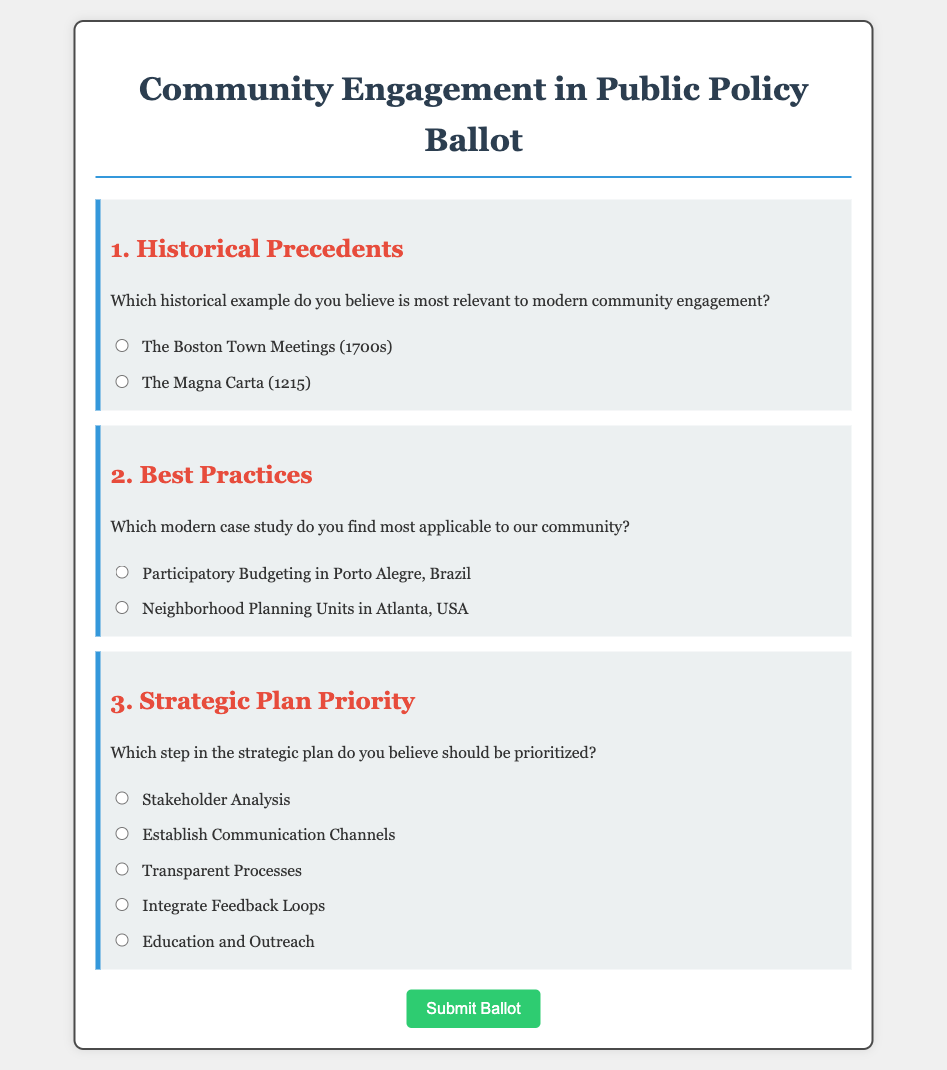What is the title of the document? The title is displayed at the top of the document, indicating the main topic of the ballot.
Answer: Community Engagement in Public Policy Ballot What are the two historical examples provided in the ballot? The historical examples are presented in a question format asking for relevance, specifically listing two options.
Answer: The Boston Town Meetings (1700s), The Magna Carta (1215) Which case study is associated with Porto Alegre? The case study related to Porto Alegre is noted among the options for modern case studies in community engagement.
Answer: Participatory Budgeting in Porto Alegre, Brazil How many steps in the strategic plan are listed? The number of steps provided for prioritization in the strategic plan can be counted from the options displayed.
Answer: Five What is the first option for strategic plan prioritization? The first option is specified as part of the systematic breakdown of strategies in the document.
Answer: Stakeholder Analysis What color is the submit button? The color of the submit button can be identified by observing its design and styling in the document.
Answer: Green Which section of the ballot is titled "Best Practices"? The title for this section is a major heading indicating the focus of the subsequent question.
Answer: Best Practices What is the purpose of the ballot? The purpose can be inferred from the title and content of the document, focusing on community involvement.
Answer: To gather opinions on community engagement in public policy 